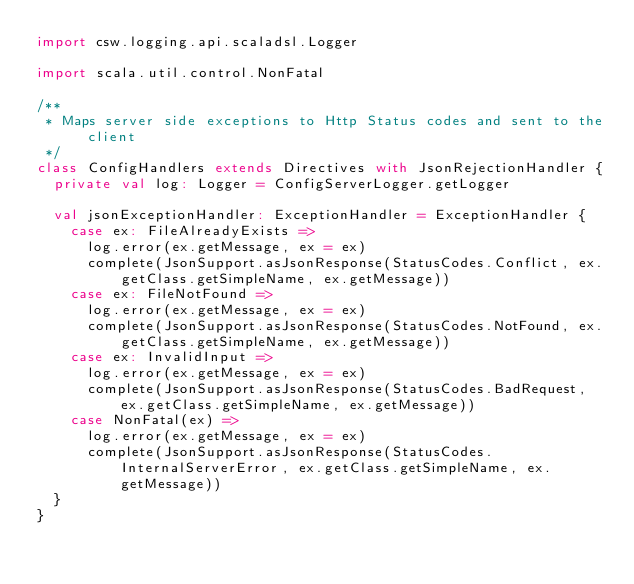<code> <loc_0><loc_0><loc_500><loc_500><_Scala_>import csw.logging.api.scaladsl.Logger

import scala.util.control.NonFatal

/**
 * Maps server side exceptions to Http Status codes and sent to the client
 */
class ConfigHandlers extends Directives with JsonRejectionHandler {
  private val log: Logger = ConfigServerLogger.getLogger

  val jsonExceptionHandler: ExceptionHandler = ExceptionHandler {
    case ex: FileAlreadyExists =>
      log.error(ex.getMessage, ex = ex)
      complete(JsonSupport.asJsonResponse(StatusCodes.Conflict, ex.getClass.getSimpleName, ex.getMessage))
    case ex: FileNotFound =>
      log.error(ex.getMessage, ex = ex)
      complete(JsonSupport.asJsonResponse(StatusCodes.NotFound, ex.getClass.getSimpleName, ex.getMessage))
    case ex: InvalidInput =>
      log.error(ex.getMessage, ex = ex)
      complete(JsonSupport.asJsonResponse(StatusCodes.BadRequest, ex.getClass.getSimpleName, ex.getMessage))
    case NonFatal(ex) =>
      log.error(ex.getMessage, ex = ex)
      complete(JsonSupport.asJsonResponse(StatusCodes.InternalServerError, ex.getClass.getSimpleName, ex.getMessage))
  }
}
</code> 